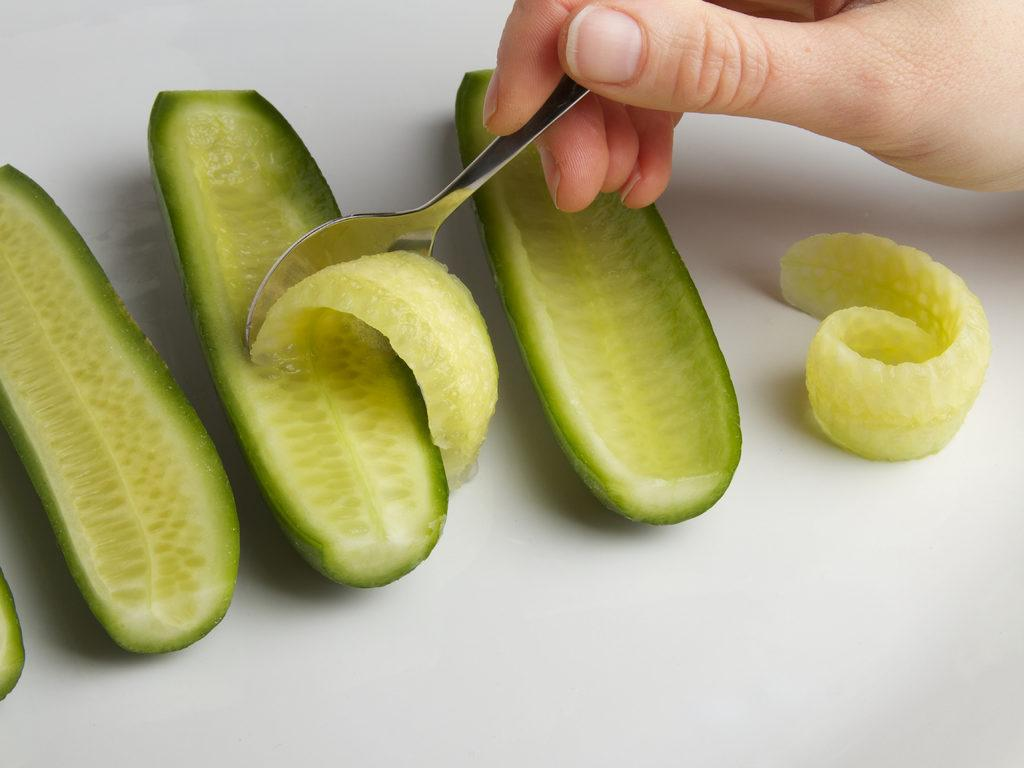What type of food can be seen in the image? There are pieces of vegetables in the image. What colors are the vegetables? The vegetables are in green and white colors. Whose hand is visible in the image? A person's hand is visible in the image. What utensil is present in the image? A spoon is present in the image. What color is the floor in the image? The floor is white in color. Can you see a flame coming from the vegetables in the image? No, there is no flame present in the image; it features pieces of vegetables and a spoon. 